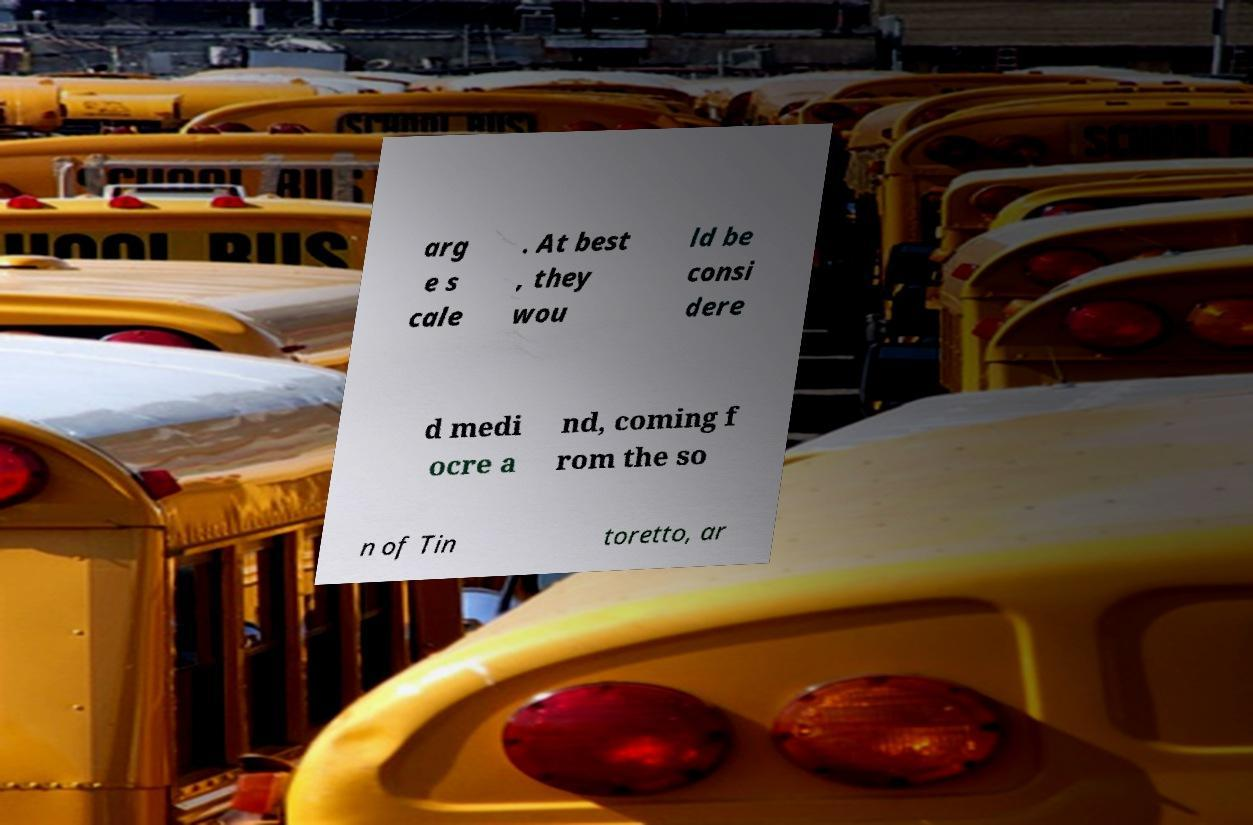What messages or text are displayed in this image? I need them in a readable, typed format. arg e s cale . At best , they wou ld be consi dere d medi ocre a nd, coming f rom the so n of Tin toretto, ar 